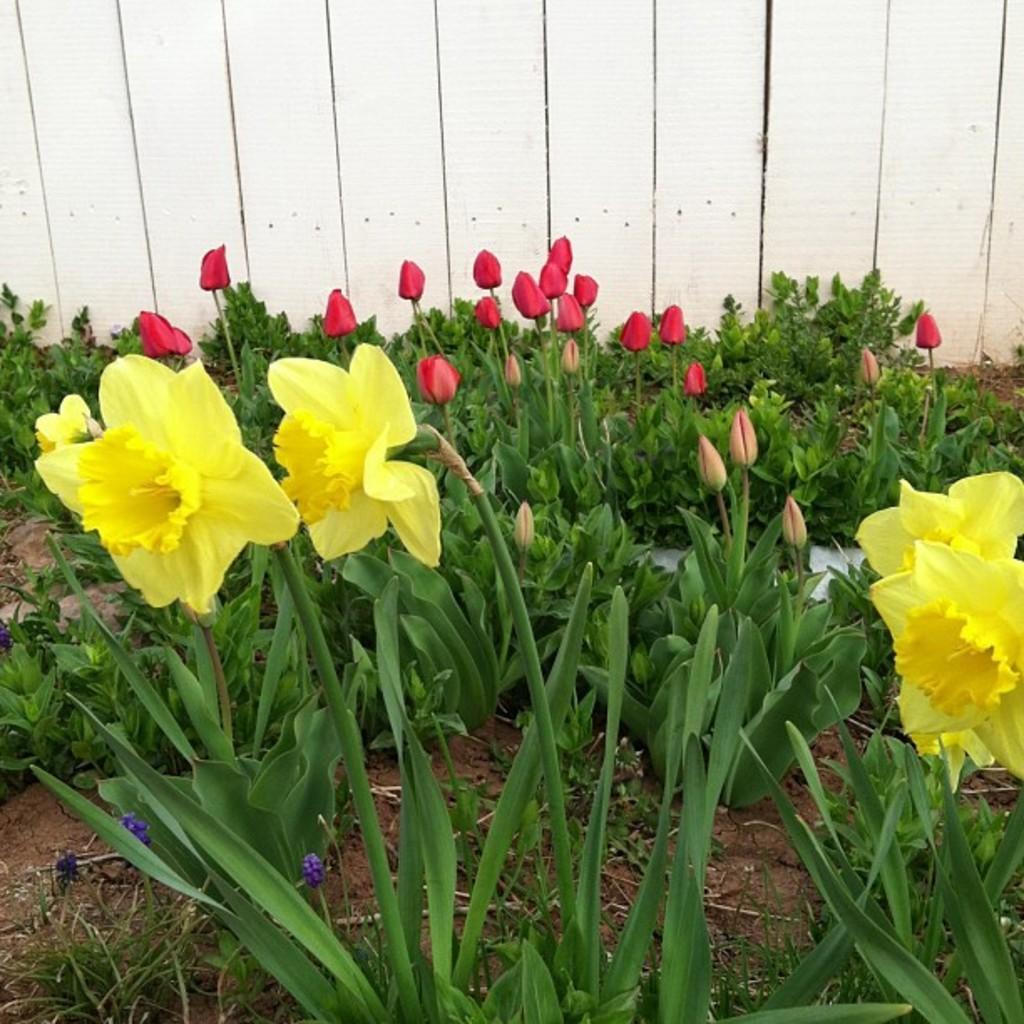Describe this image in one or two sentences. In this image I can see the flowers to the plants. These flowers are in yellow and red color. In the background I can see the wooden wall. 